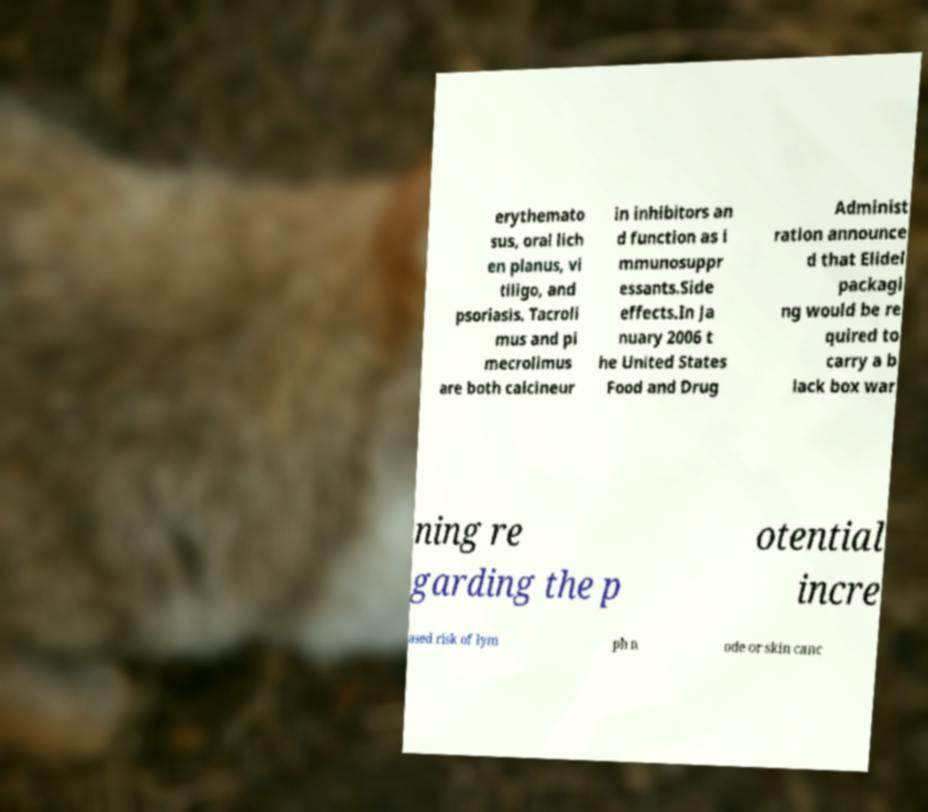Can you accurately transcribe the text from the provided image for me? erythemato sus, oral lich en planus, vi tiligo, and psoriasis. Tacroli mus and pi mecrolimus are both calcineur in inhibitors an d function as i mmunosuppr essants.Side effects.In Ja nuary 2006 t he United States Food and Drug Administ ration announce d that Elidel packagi ng would be re quired to carry a b lack box war ning re garding the p otential incre ased risk of lym ph n ode or skin canc 